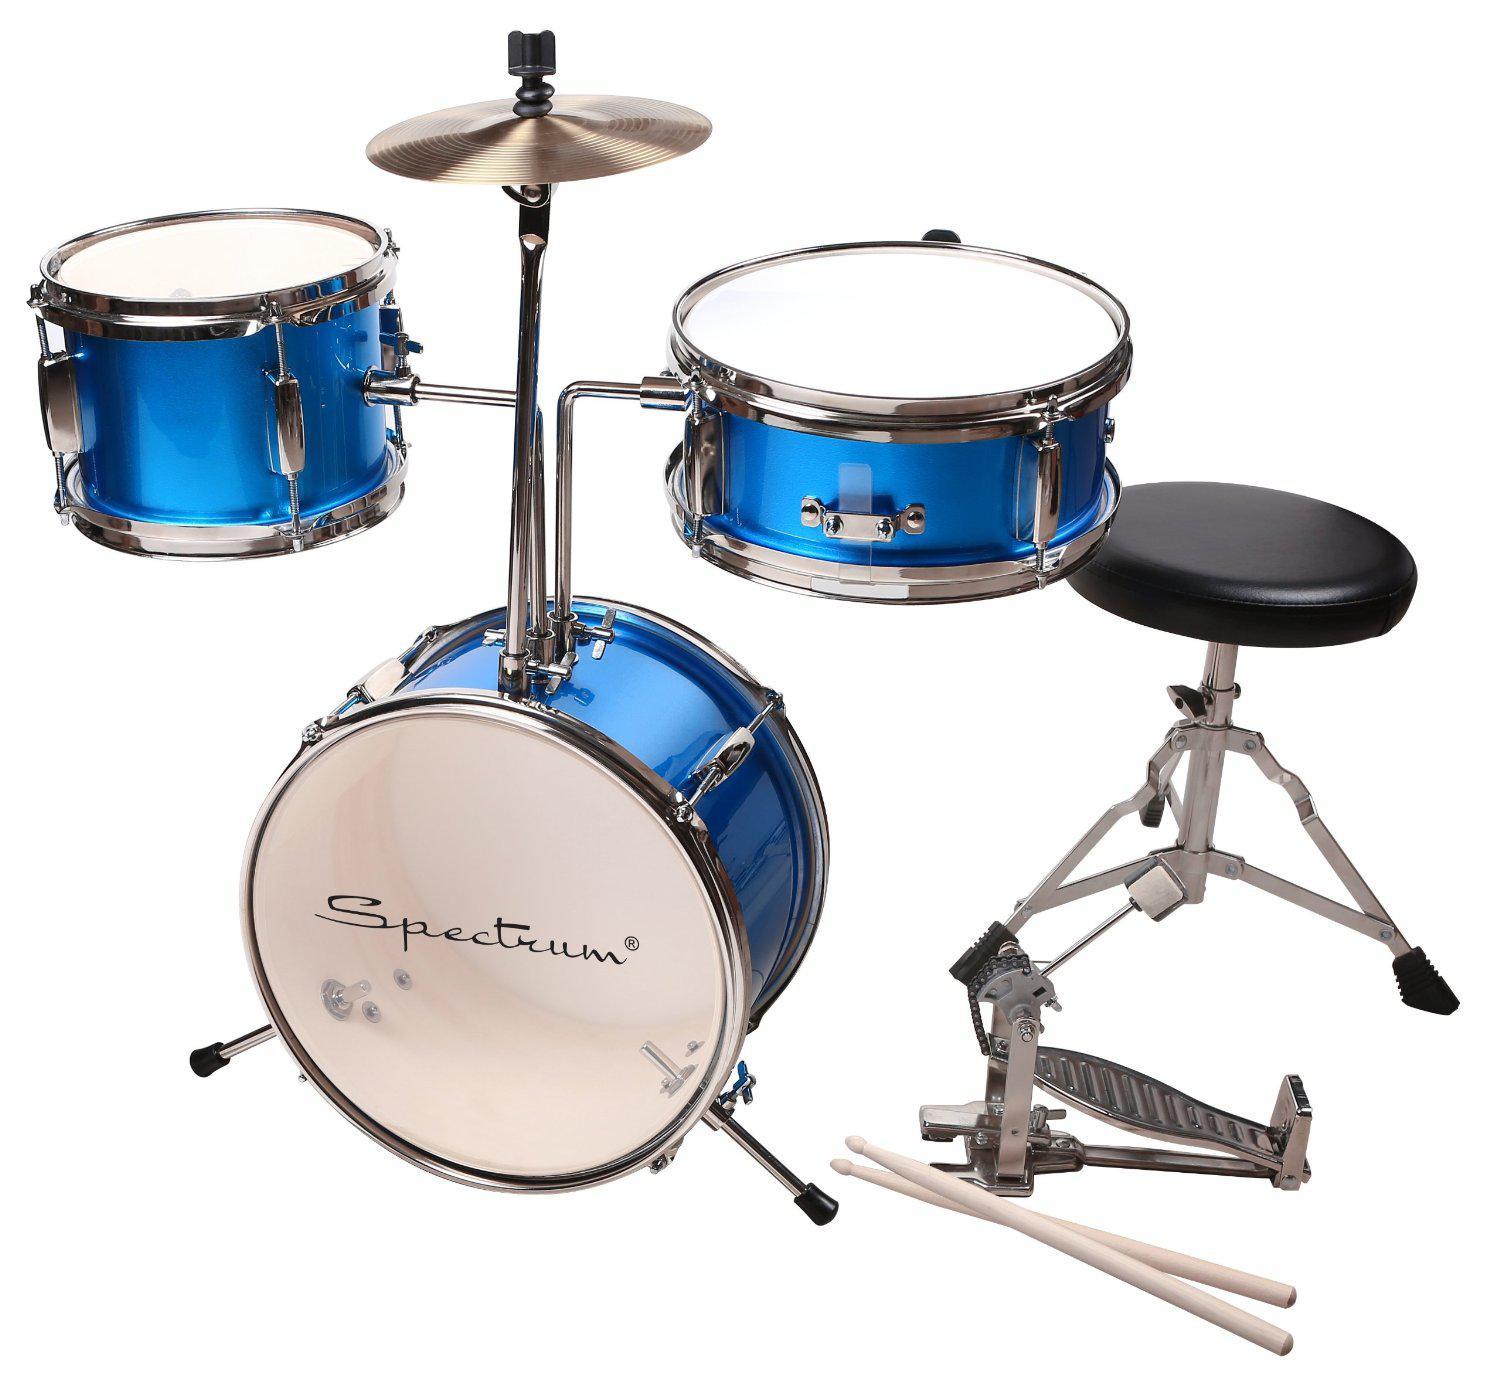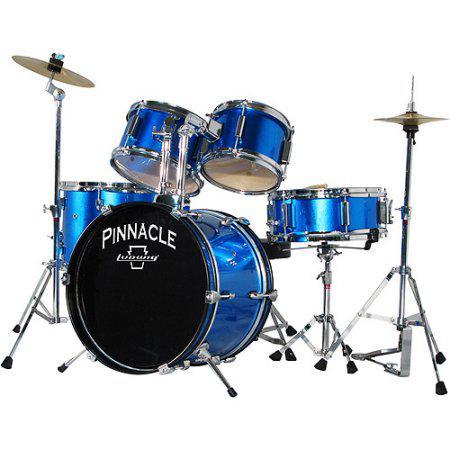The first image is the image on the left, the second image is the image on the right. Assess this claim about the two images: "One of the kick drums has a black front.". Correct or not? Answer yes or no. Yes. The first image is the image on the left, the second image is the image on the right. Assess this claim about the two images: "The drumkit on the right has a large drum positioned on its side with a black face showing, and the drumkit on the left has a large drum with a white face.". Correct or not? Answer yes or no. Yes. 